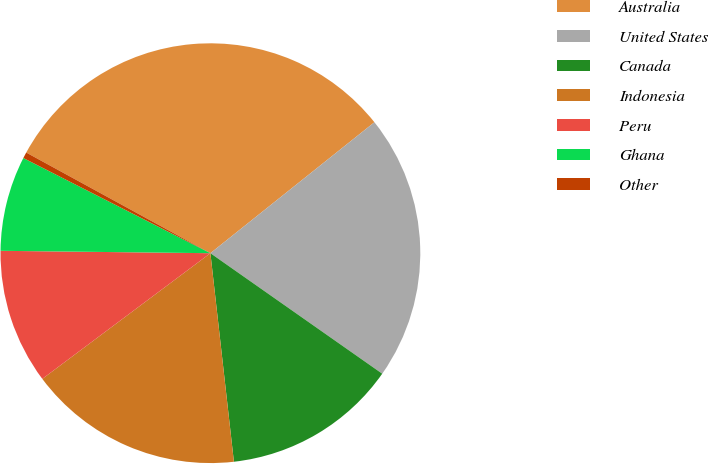<chart> <loc_0><loc_0><loc_500><loc_500><pie_chart><fcel>Australia<fcel>United States<fcel>Canada<fcel>Indonesia<fcel>Peru<fcel>Ghana<fcel>Other<nl><fcel>31.32%<fcel>20.46%<fcel>13.48%<fcel>16.57%<fcel>10.4%<fcel>7.31%<fcel>0.47%<nl></chart> 